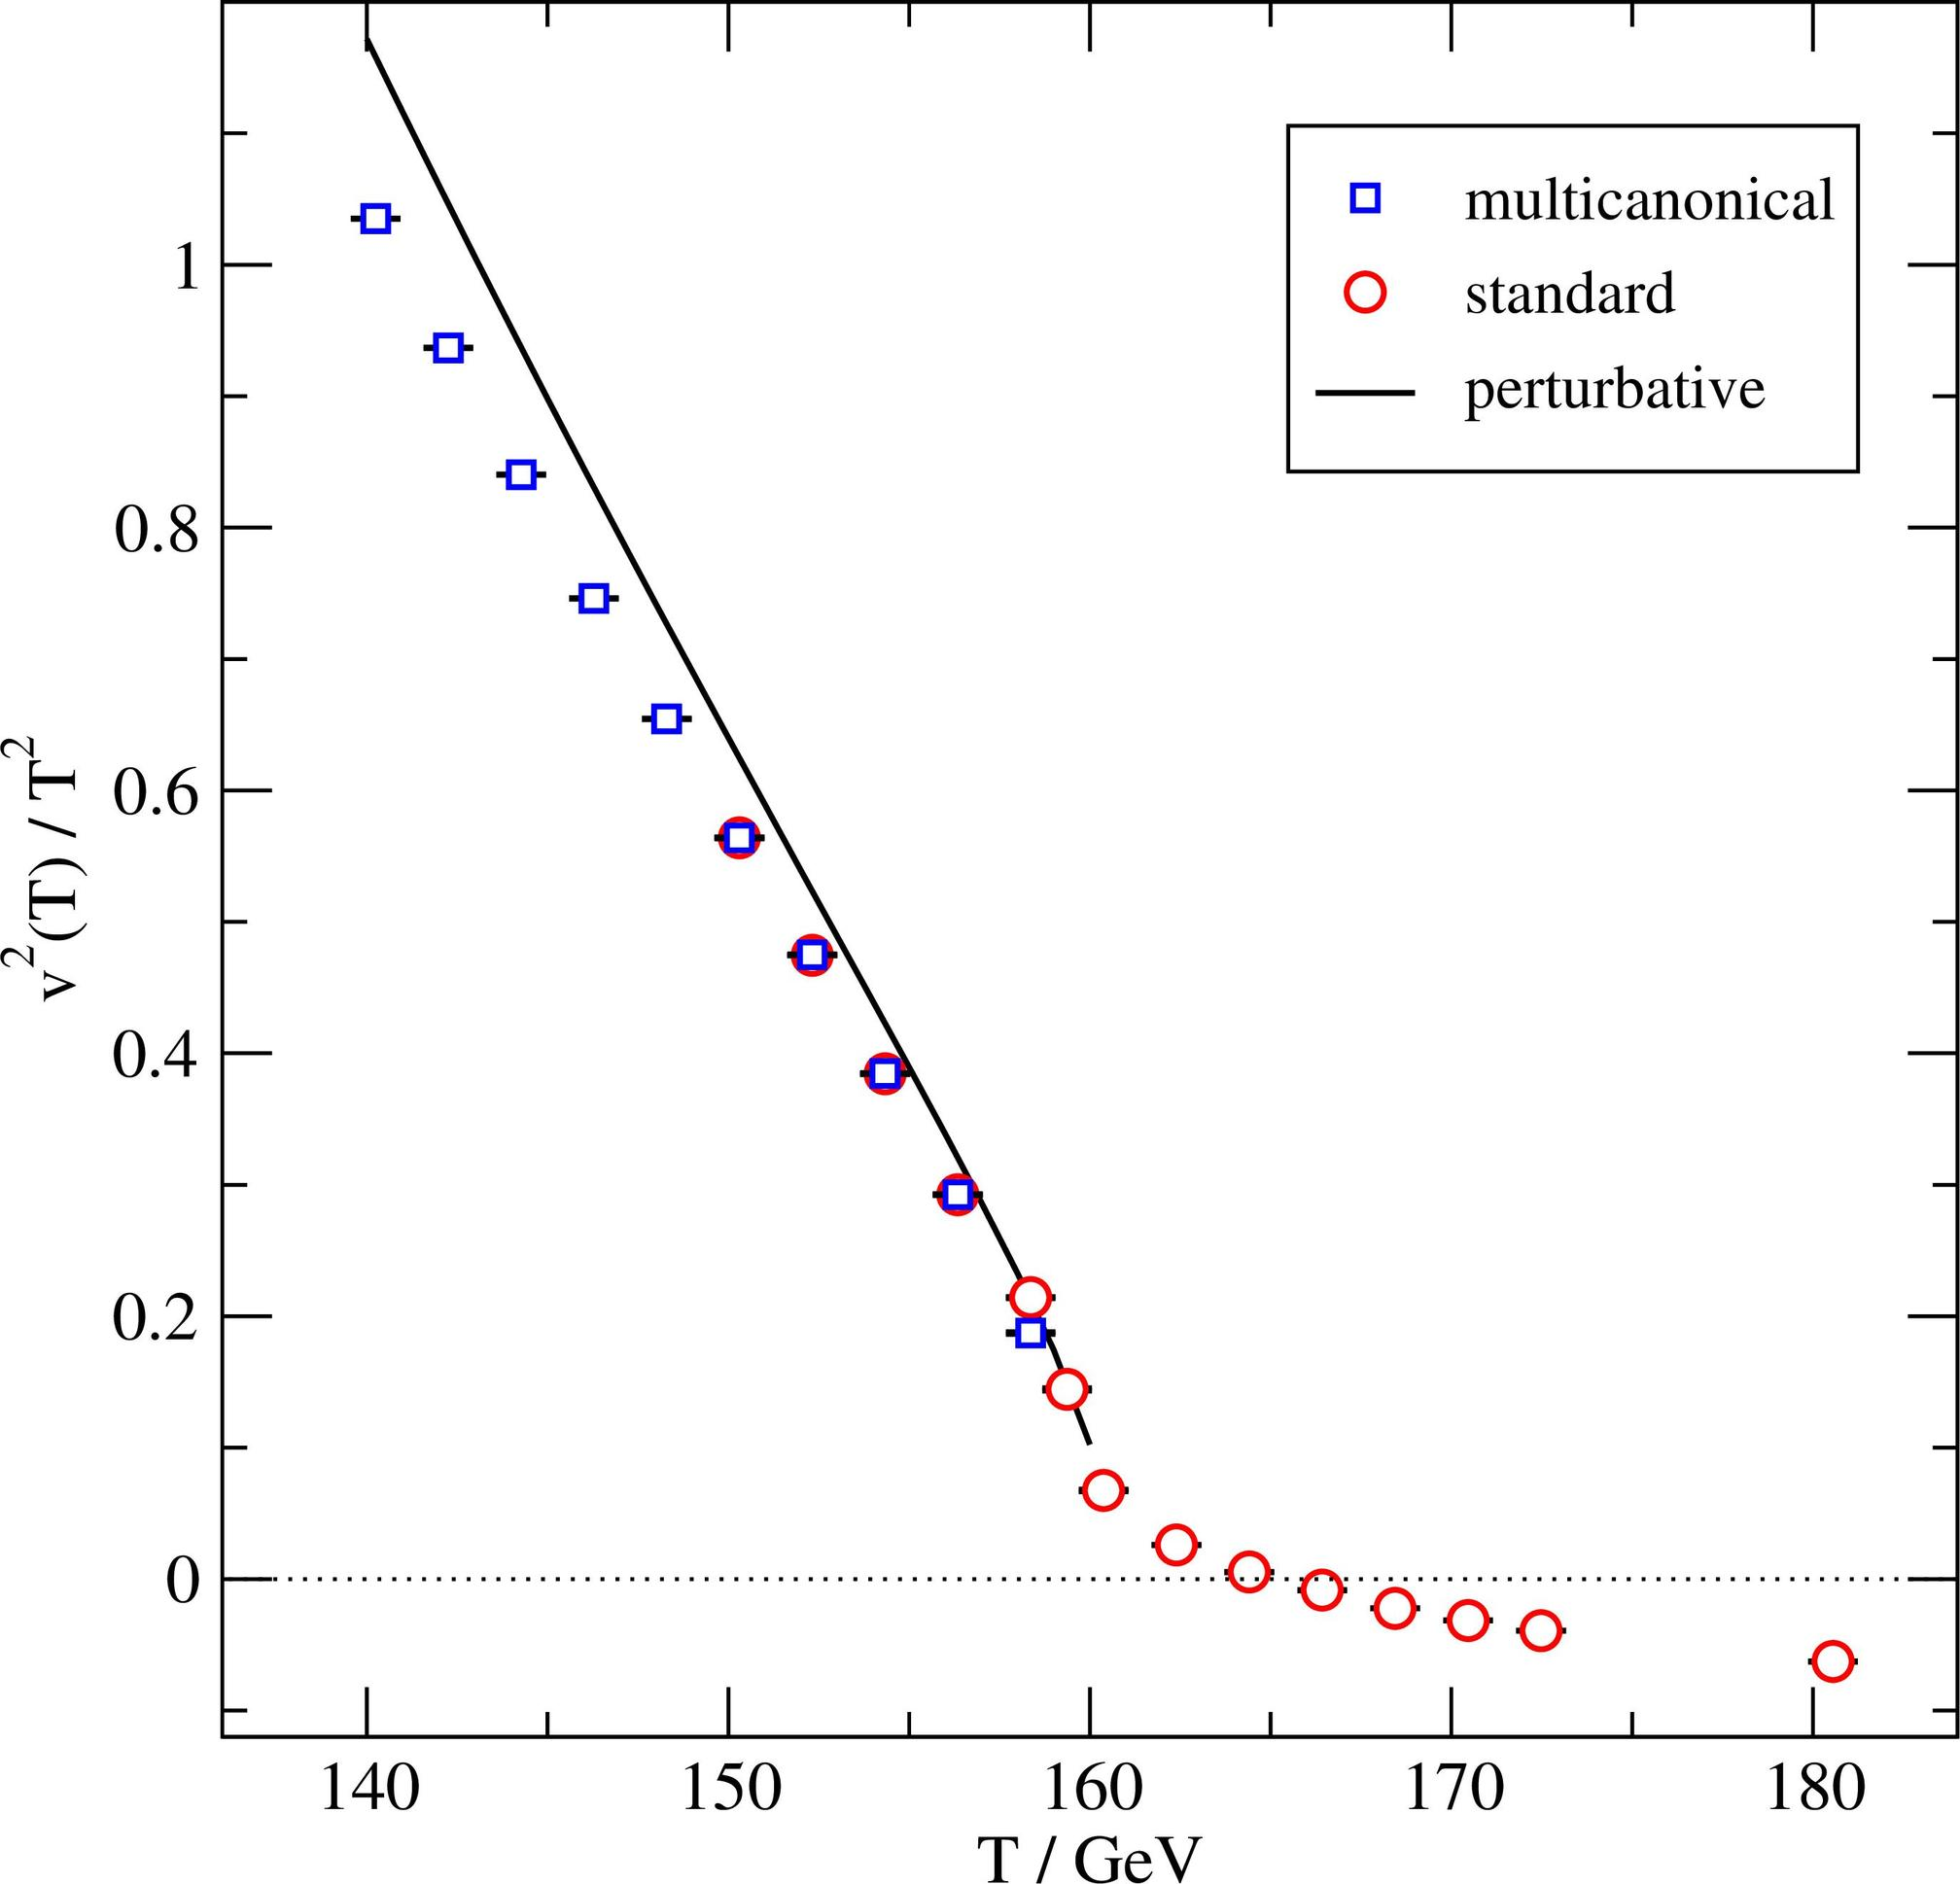Based on the figure, at what temperature range does the discrepancy between the multicanonical and standard measurements become most pronounced? A. 140-150 GeV B. 150-160 GeV C. 160-170 GeV D. 170-180 GeV - The separation between the blue squares (multicanonical) and the red circles (standard) is the greatest at the temperature range of 160-170 GeV, indicating the largest discrepancy in measurements within this range. Therefore, the correct answer is C. 